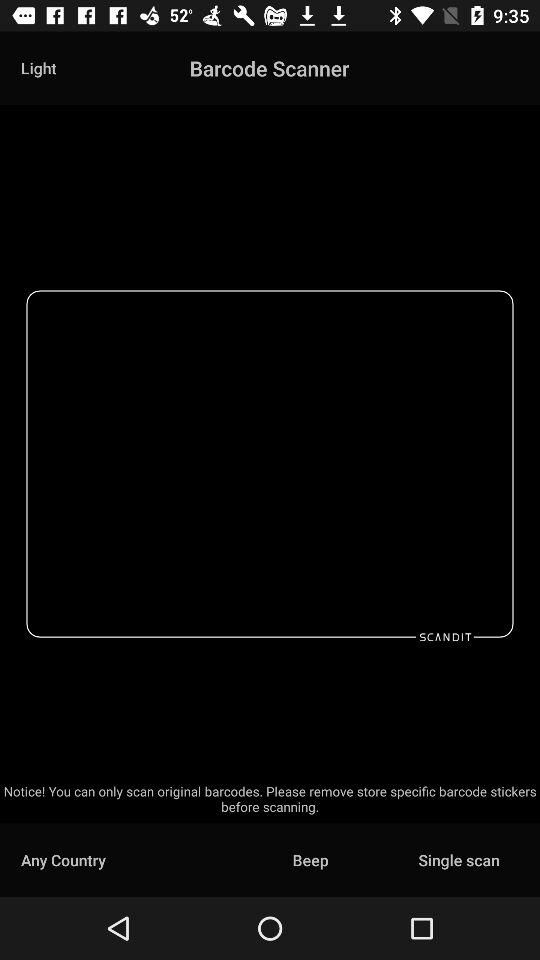What is the application name? The application name is "Barcode Scanner". 